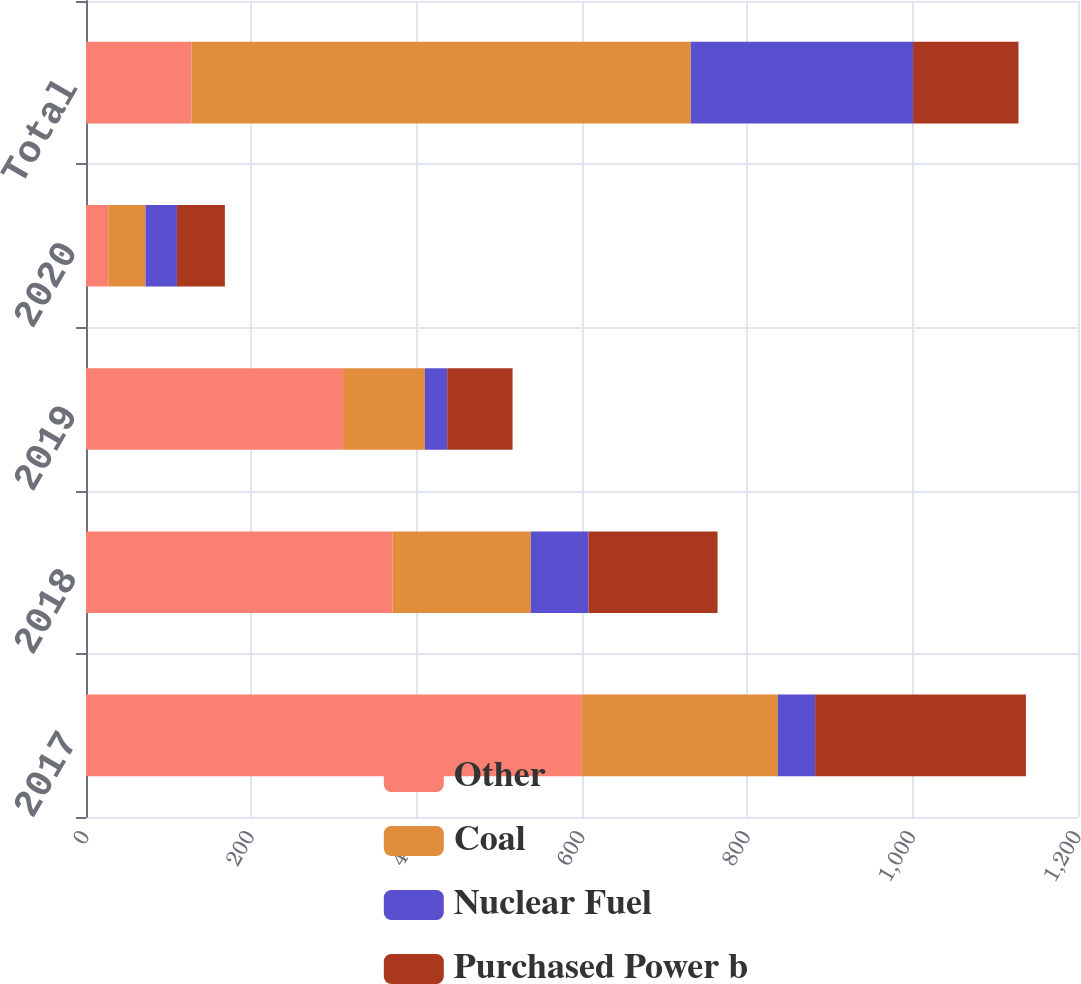Convert chart to OTSL. <chart><loc_0><loc_0><loc_500><loc_500><stacked_bar_chart><ecel><fcel>2017<fcel>2018<fcel>2019<fcel>2020<fcel>Total<nl><fcel>Other<fcel>599<fcel>371<fcel>311<fcel>27<fcel>127.5<nl><fcel>Coal<fcel>238<fcel>167<fcel>99<fcel>45<fcel>604<nl><fcel>Nuclear Fuel<fcel>45<fcel>70<fcel>27<fcel>38<fcel>269<nl><fcel>Purchased Power b<fcel>255<fcel>156<fcel>79<fcel>58<fcel>127.5<nl></chart> 